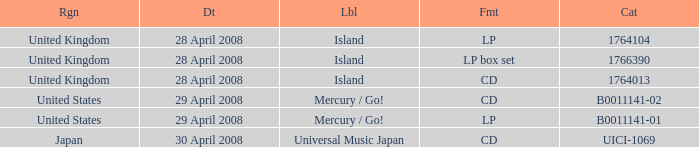What is the Region of the 1766390 Catalog? United Kingdom. 